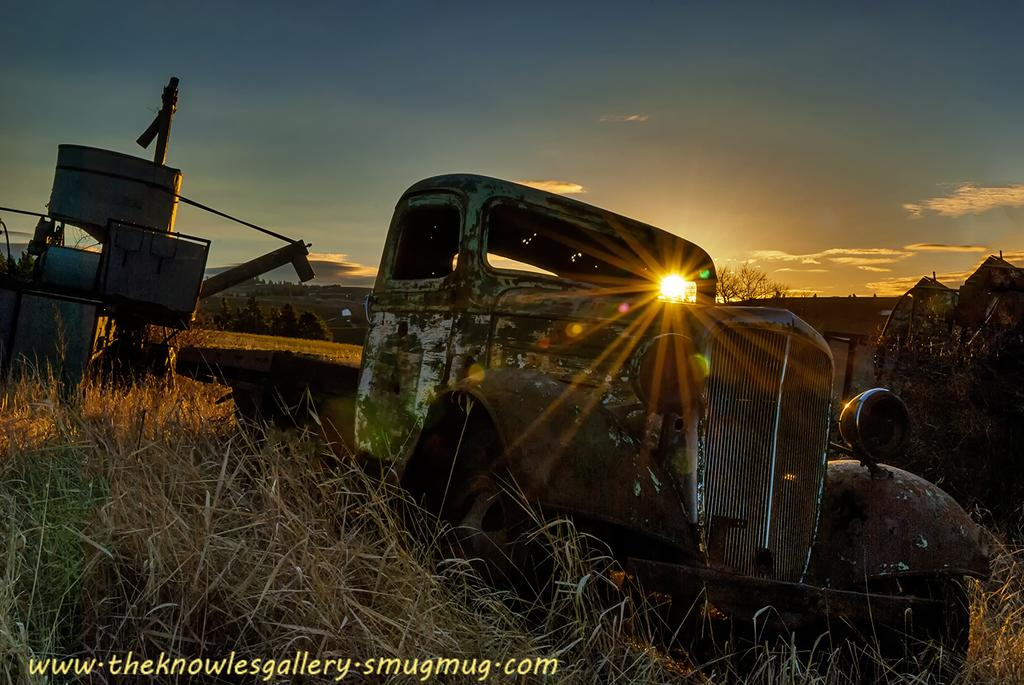What types of objects are present in the image? There are vehicles in the image. What kind of vegetation can be seen in the image? There is dried grass and green grass in the image. What is visible in the background of the image? The sun is visible in the background of the image. What is the color of the sky in the image? The sky is blue and white in color. What type of oven can be seen in the image? There is no oven present in the image. Are there any stockings visible on the vehicles in the image? There are no stockings present in the image. 